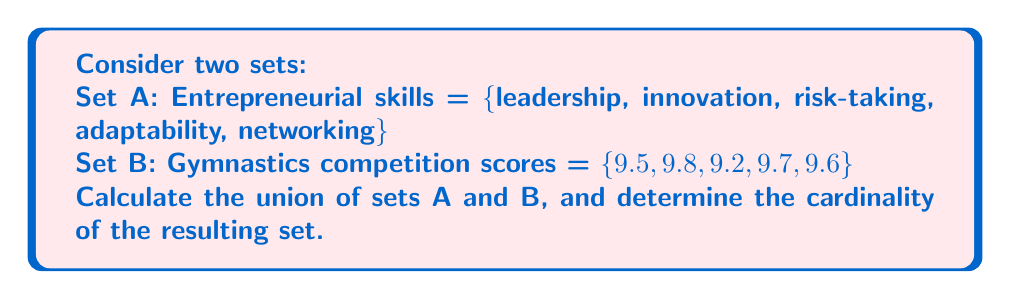Could you help me with this problem? To solve this problem, we need to follow these steps:

1. Understand the given sets:
   Set A = {leadership, innovation, risk-taking, adaptability, networking}
   Set B = {9.5, 9.8, 9.2, 9.7, 9.6}

2. Recall the definition of union:
   The union of two sets A and B, denoted as $A \cup B$, is the set of all elements that are in A, in B, or in both A and B.

3. Combine the elements of both sets:
   $A \cup B$ = {leadership, innovation, risk-taking, adaptability, networking, 9.5, 9.8, 9.2, 9.7, 9.6}

4. Count the number of elements in the resulting set:
   The cardinality of a set, denoted as $|A \cup B|$, is the number of elements in the set.
   In this case, $|A \cup B| = 10$

Note that there are no common elements between sets A and B, so all elements from both sets are included in the union without any duplicates.
Answer: $A \cup B$ = {leadership, innovation, risk-taking, adaptability, networking, 9.5, 9.8, 9.2, 9.7, 9.6}
$|A \cup B| = 10$ 